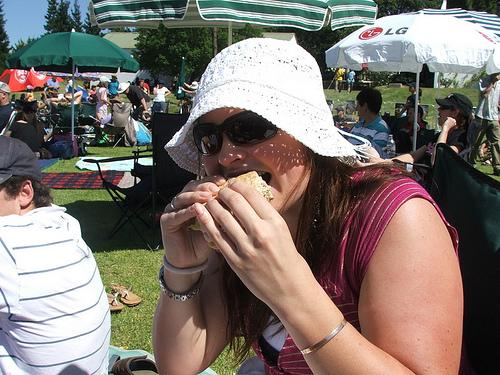What is the woman doing with the object in her hand?

Choices:
A) throwing it
B) passing it
C) trading it
D) eating it eating it 